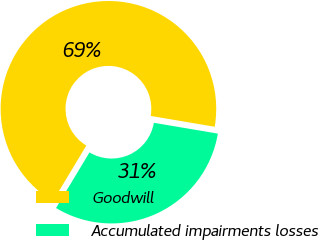Convert chart to OTSL. <chart><loc_0><loc_0><loc_500><loc_500><pie_chart><fcel>Goodwill<fcel>Accumulated impairments losses<nl><fcel>69.05%<fcel>30.95%<nl></chart> 